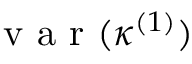<formula> <loc_0><loc_0><loc_500><loc_500>v a r ( \kappa ^ { ( 1 ) } )</formula> 